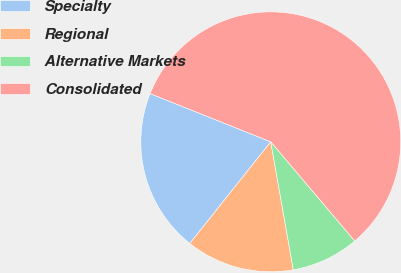Convert chart to OTSL. <chart><loc_0><loc_0><loc_500><loc_500><pie_chart><fcel>Specialty<fcel>Regional<fcel>Alternative Markets<fcel>Consolidated<nl><fcel>20.35%<fcel>13.48%<fcel>8.41%<fcel>57.77%<nl></chart> 